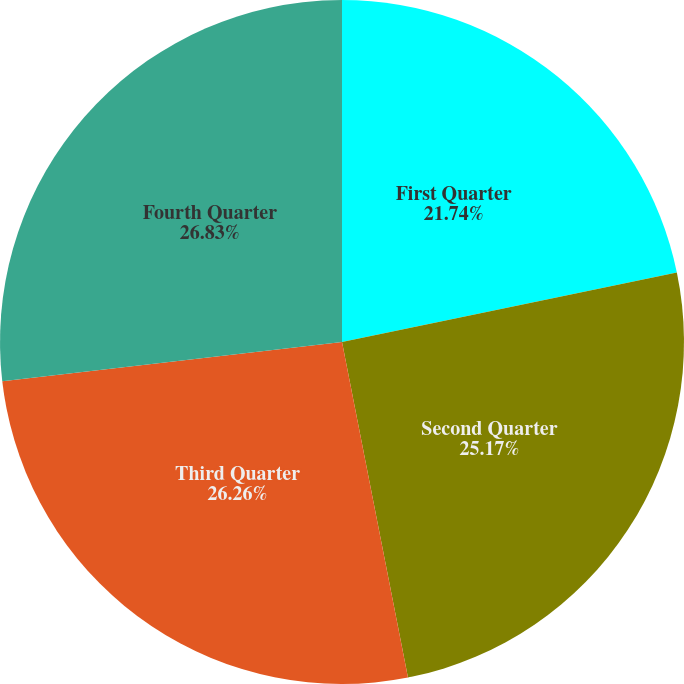<chart> <loc_0><loc_0><loc_500><loc_500><pie_chart><fcel>First Quarter<fcel>Second Quarter<fcel>Third Quarter<fcel>Fourth Quarter<nl><fcel>21.74%<fcel>25.17%<fcel>26.26%<fcel>26.83%<nl></chart> 